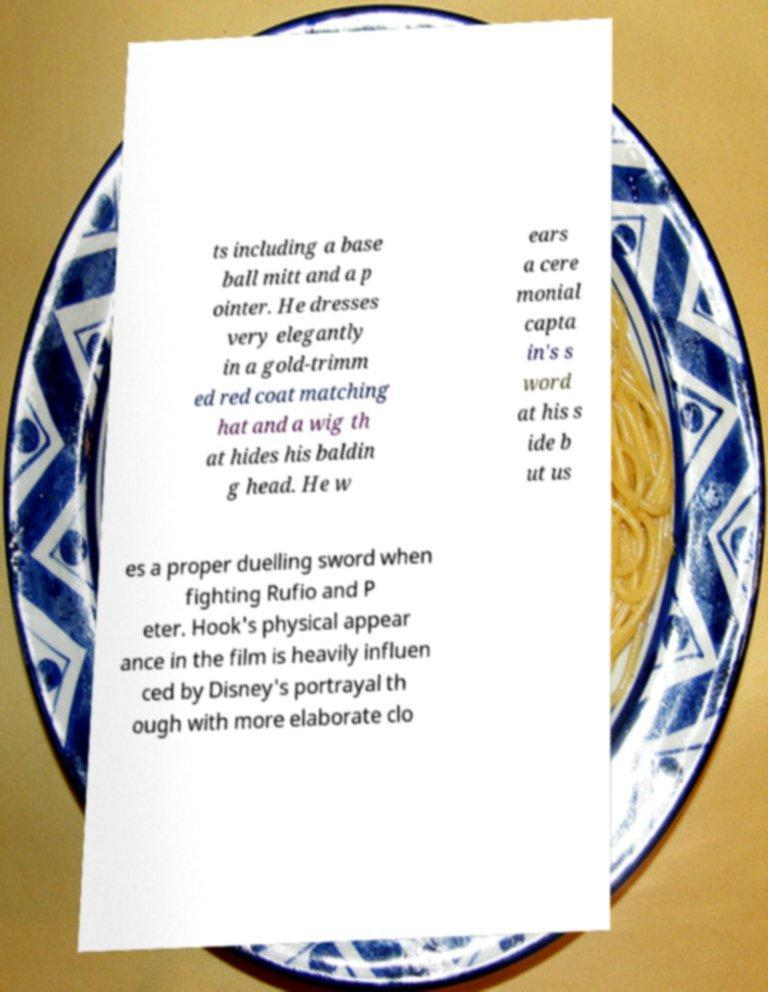What messages or text are displayed in this image? I need them in a readable, typed format. ts including a base ball mitt and a p ointer. He dresses very elegantly in a gold-trimm ed red coat matching hat and a wig th at hides his baldin g head. He w ears a cere monial capta in's s word at his s ide b ut us es a proper duelling sword when fighting Rufio and P eter. Hook's physical appear ance in the film is heavily influen ced by Disney's portrayal th ough with more elaborate clo 